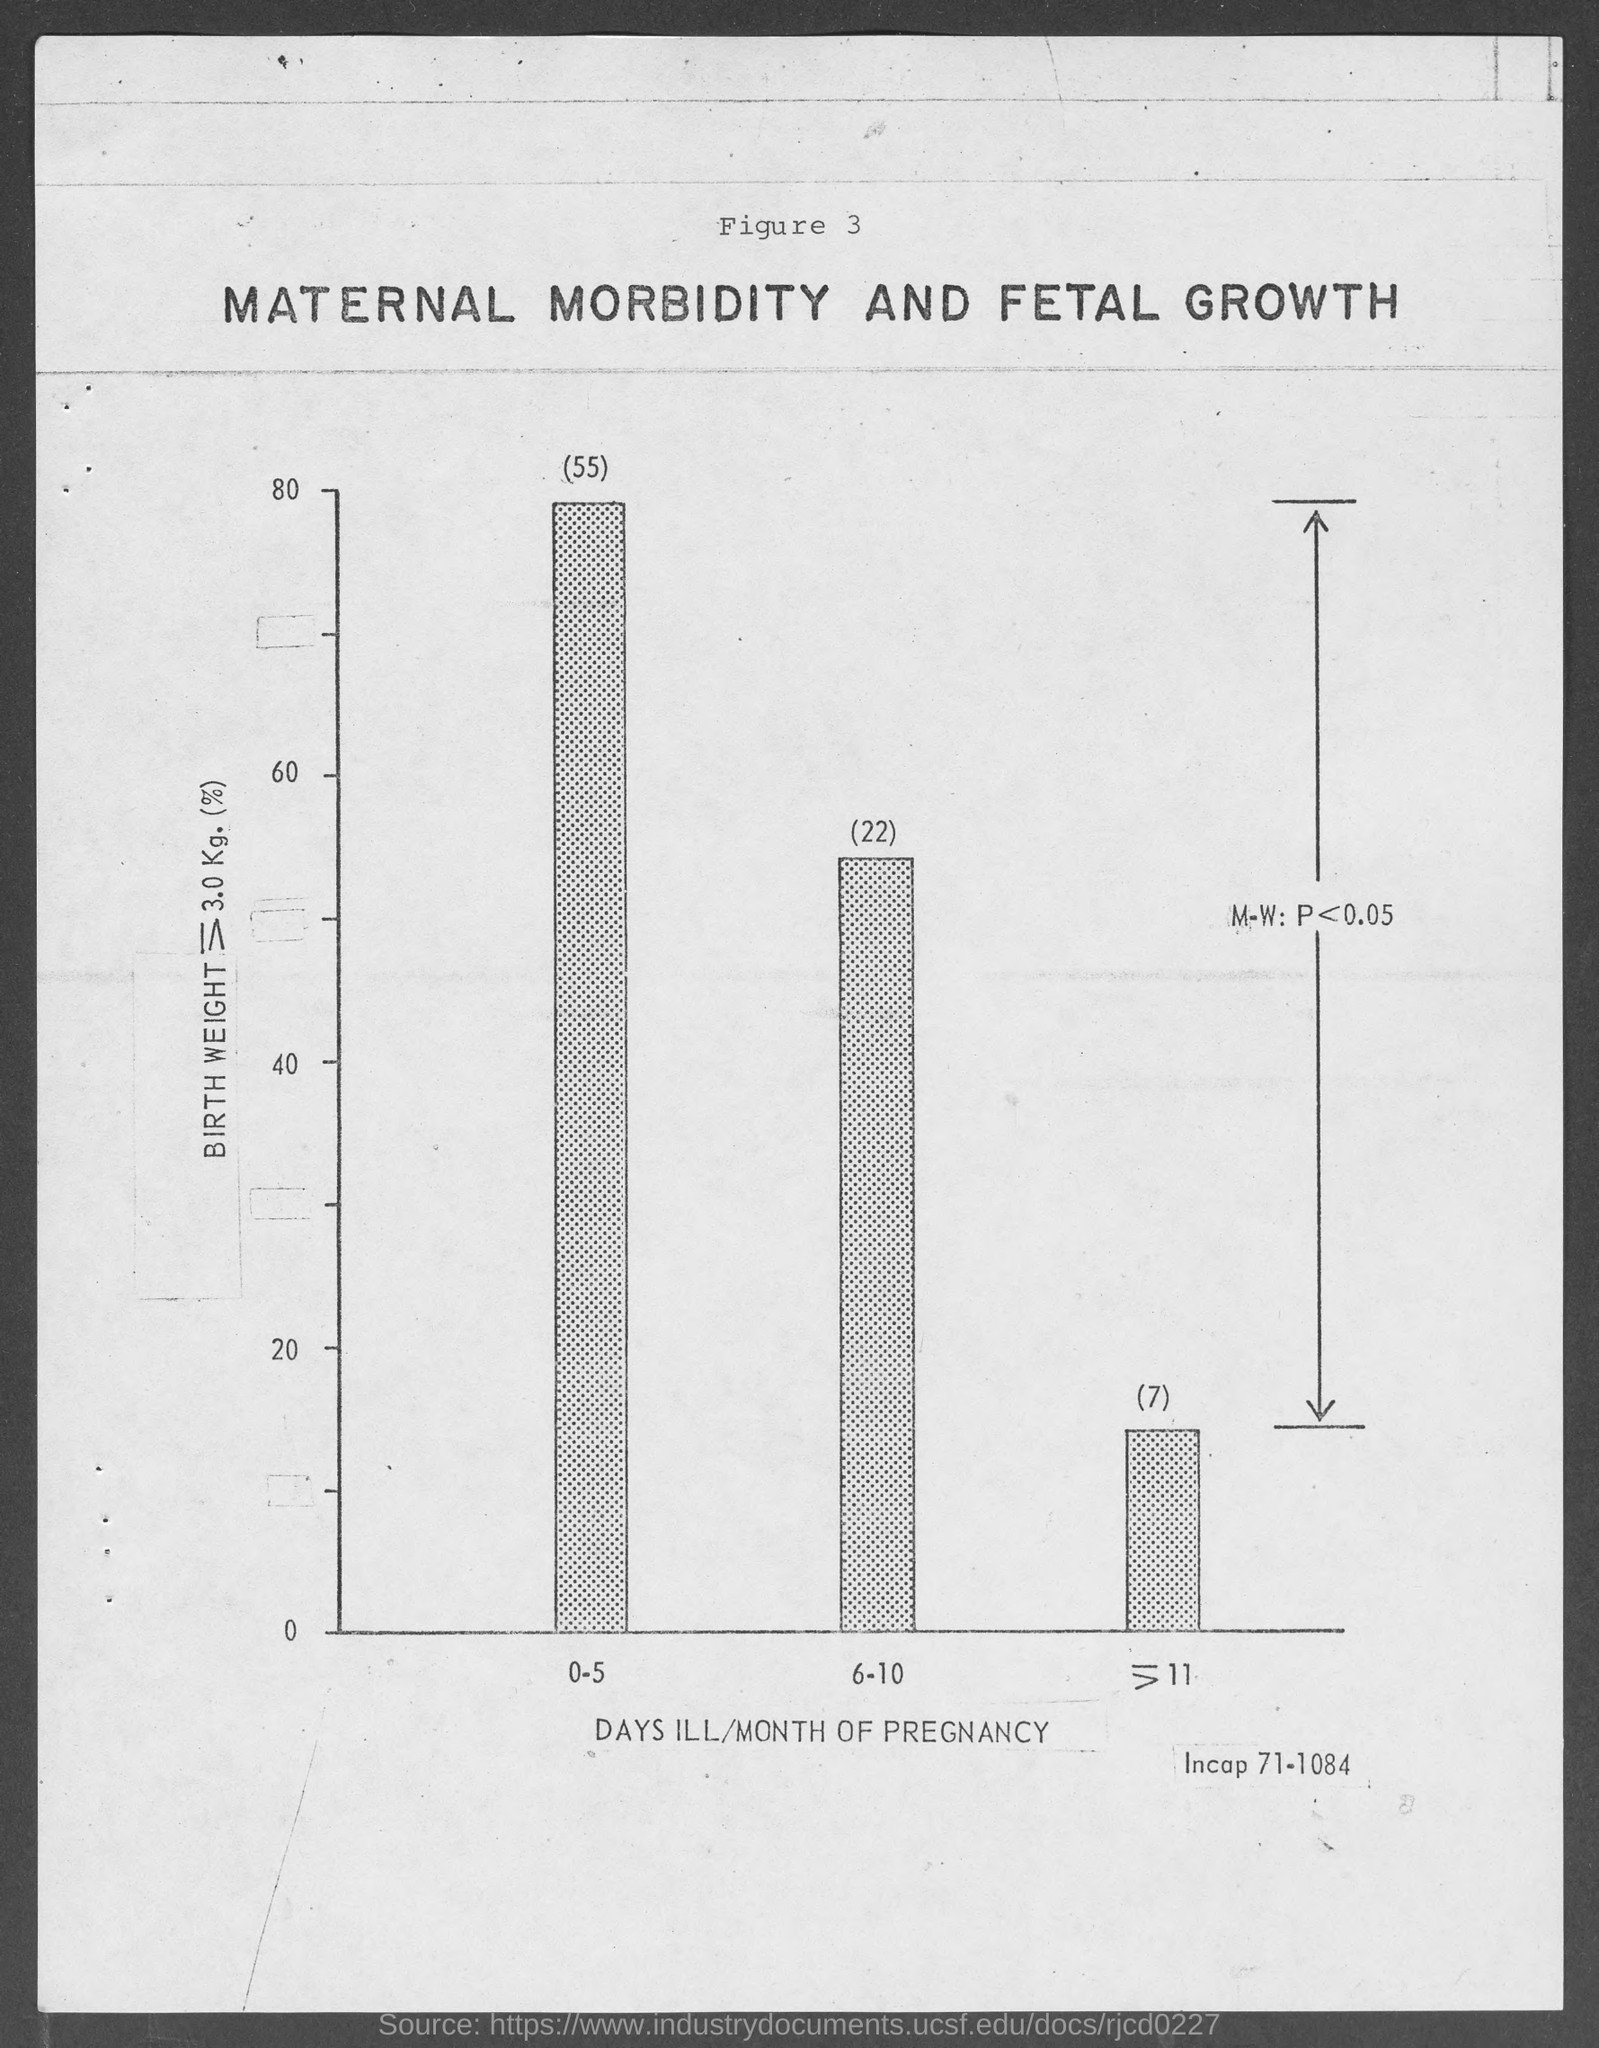Give some essential details in this illustration. The X-axis of the graph represents the number of days of illness per month during pregnancy. 